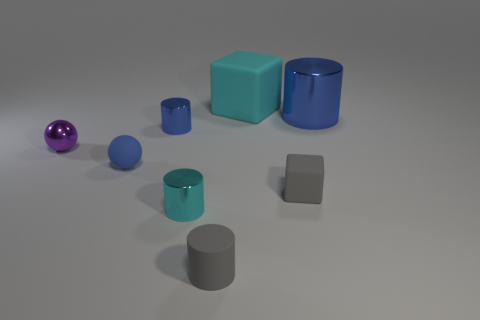Add 2 tiny gray rubber balls. How many objects exist? 10 Subtract all shiny cylinders. How many cylinders are left? 1 Subtract all blue cylinders. How many cylinders are left? 2 Subtract all balls. How many objects are left? 6 Add 8 small blue shiny cylinders. How many small blue shiny cylinders are left? 9 Add 5 rubber balls. How many rubber balls exist? 6 Subtract 0 purple cubes. How many objects are left? 8 Subtract 1 cubes. How many cubes are left? 1 Subtract all gray cylinders. Subtract all yellow cubes. How many cylinders are left? 3 Subtract all purple blocks. How many blue balls are left? 1 